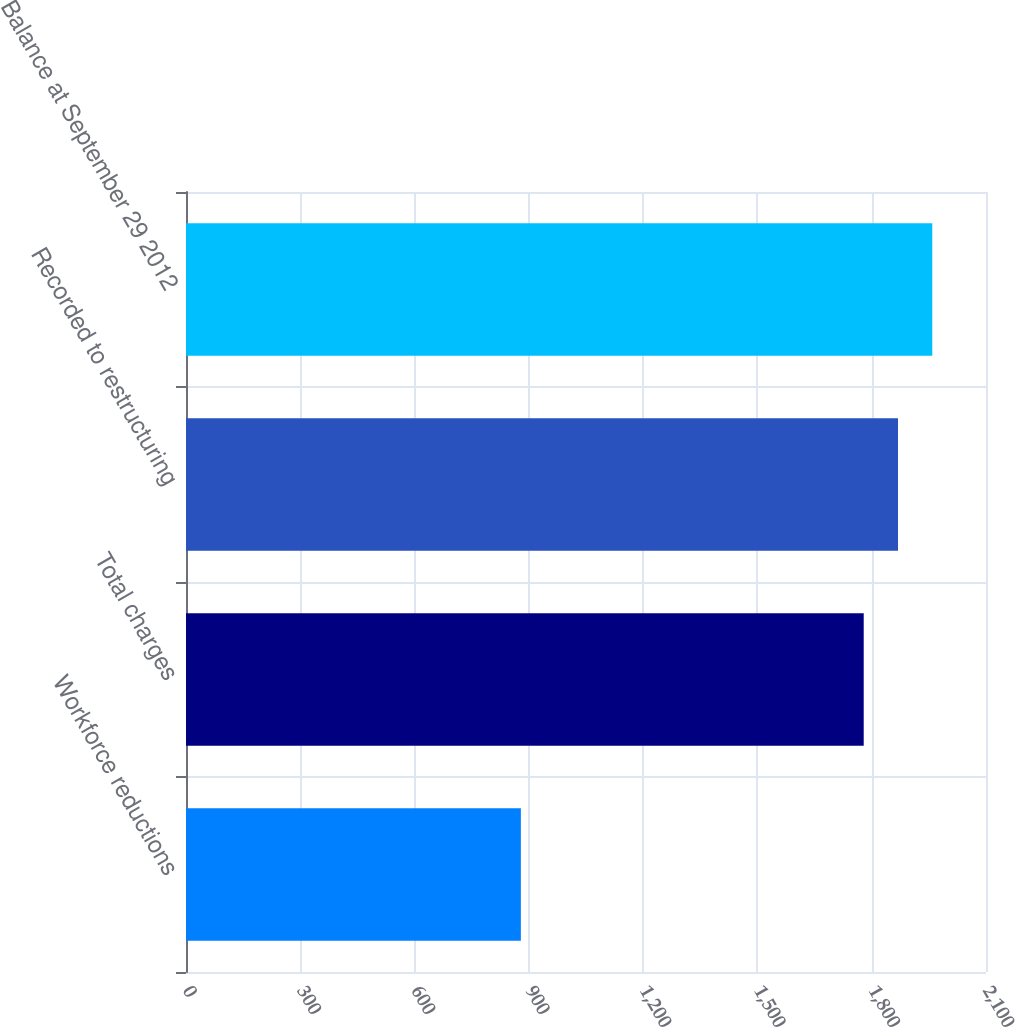Convert chart to OTSL. <chart><loc_0><loc_0><loc_500><loc_500><bar_chart><fcel>Workforce reductions<fcel>Total charges<fcel>Recorded to restructuring<fcel>Balance at September 29 2012<nl><fcel>879<fcel>1779<fcel>1869<fcel>1959<nl></chart> 